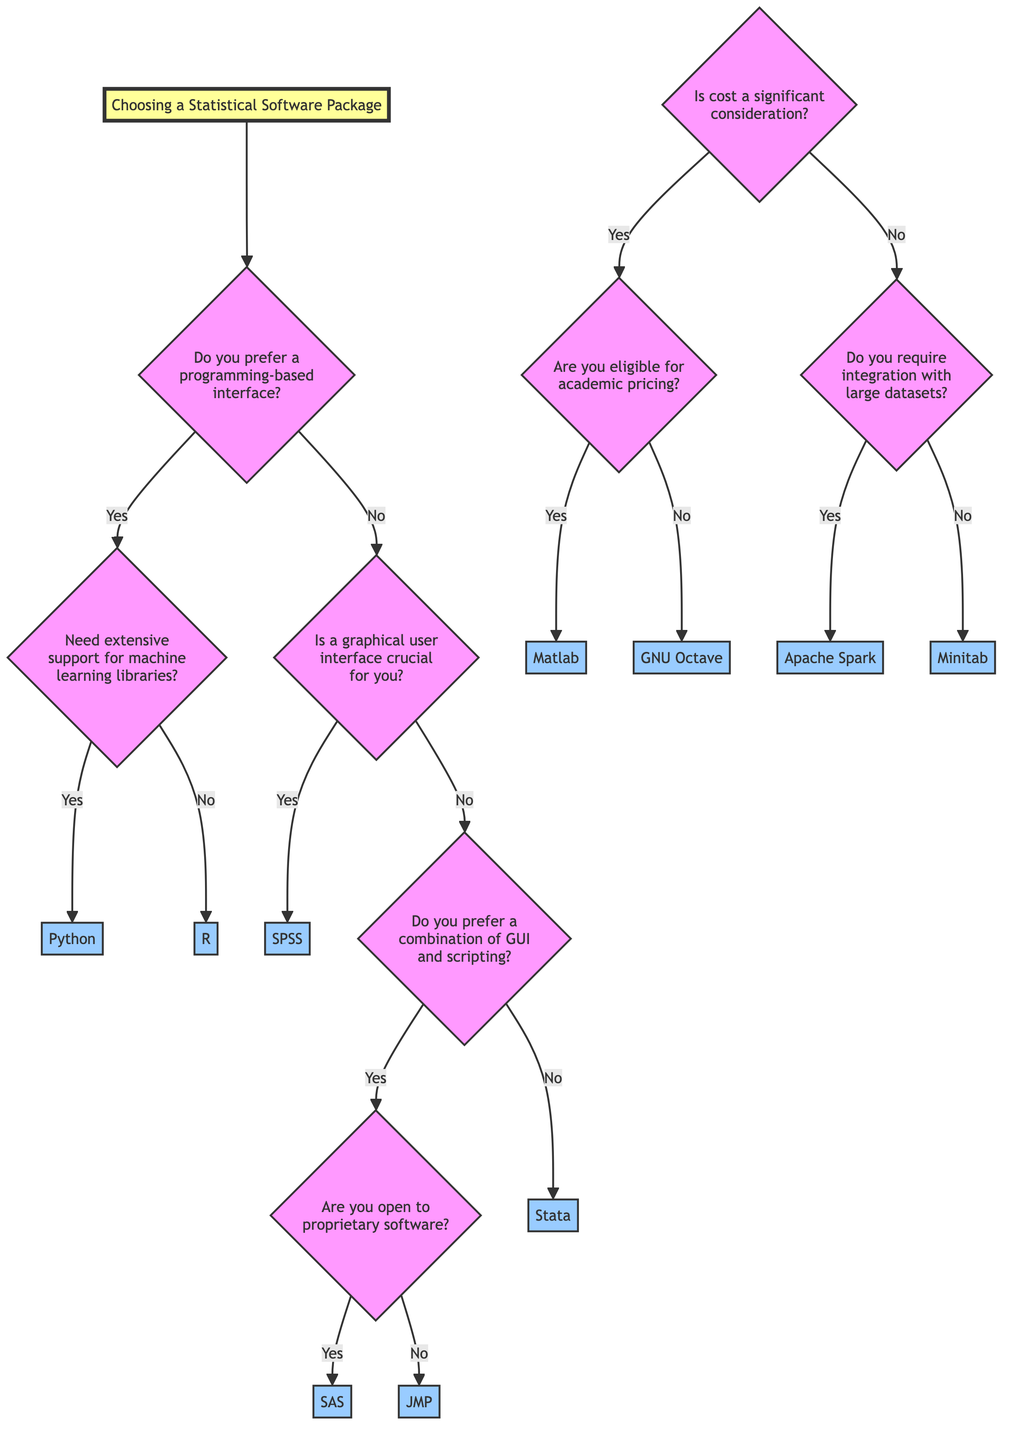What are the two main branches in the decision tree? The decision tree begins with two main branches: one for programming-based interfaces and another for those not preferring programming-based interfaces.
Answer: Programming-based interface and non-programming-based interface What software option is provided for users needing extensive support for machine learning libraries? If a user prefers a programming-based interface and needs extensive support for machine learning libraries, the option listed is Python, which utilizes libraries such as scikit-learn and TensorFlow.
Answer: Python Is SPSS recommended for users who prioritize a graphical user interface? The decision tree clearly states that for those who do prioritize a graphical user interface, the option provided is SPSS based on the user's preference.
Answer: SPSS What software is suggested if cost is not a concern and large dataset integration is required? The decision tree indicates that if a user does not find cost to be significant and requires integration with large datasets, the suggested software option is Apache Spark.
Answer: Apache Spark How many total software options are presented in the diagram? By analyzing the decision paths in the diagram, there are a total of six distinct software options indicated: Python, R, SPSS, SAS, JMP, and Apache Spark.
Answer: Six What is the first decision point in the tree? The first question in the decision-making process asks if the user prefers a programming-based interface, which is the initial decision point before proceeding further.
Answer: Do you prefer a programming-based interface? What is the outcome if a user does not need a programming-based interface and is not open to proprietary software? For users who do not need a programming-based interface and are not open to proprietary software, the result will lead them to the option of choosing Stata as their software package.
Answer: Stata Which software package is recommended if a user is eligible for academic pricing? The diagram indicates that if a user is considering cost and is eligible for academic pricing, the recommended software package would be Matlab with an academic license.
Answer: Matlab (with academic license) What branching question follows after deciding on a non-programming-based interface? The question that follows for users who decide against a programming-based interface is whether a graphical user interface is crucial for them, which leads to further possible options.
Answer: Is a graphical user interface crucial for you? 